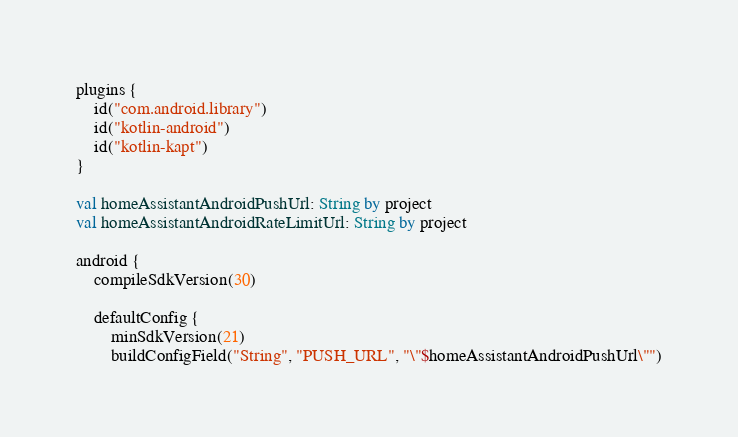Convert code to text. <code><loc_0><loc_0><loc_500><loc_500><_Kotlin_>plugins {
    id("com.android.library")
    id("kotlin-android")
    id("kotlin-kapt")
}

val homeAssistantAndroidPushUrl: String by project
val homeAssistantAndroidRateLimitUrl: String by project

android {
    compileSdkVersion(30)

    defaultConfig {
        minSdkVersion(21)
        buildConfigField("String", "PUSH_URL", "\"$homeAssistantAndroidPushUrl\"")</code> 